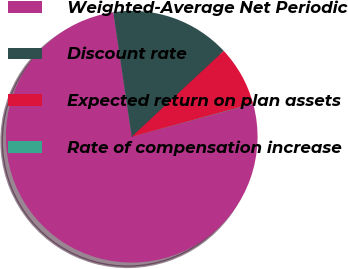Convert chart. <chart><loc_0><loc_0><loc_500><loc_500><pie_chart><fcel>Weighted-Average Net Periodic<fcel>Discount rate<fcel>Expected return on plan assets<fcel>Rate of compensation increase<nl><fcel>76.87%<fcel>15.39%<fcel>7.71%<fcel>0.03%<nl></chart> 